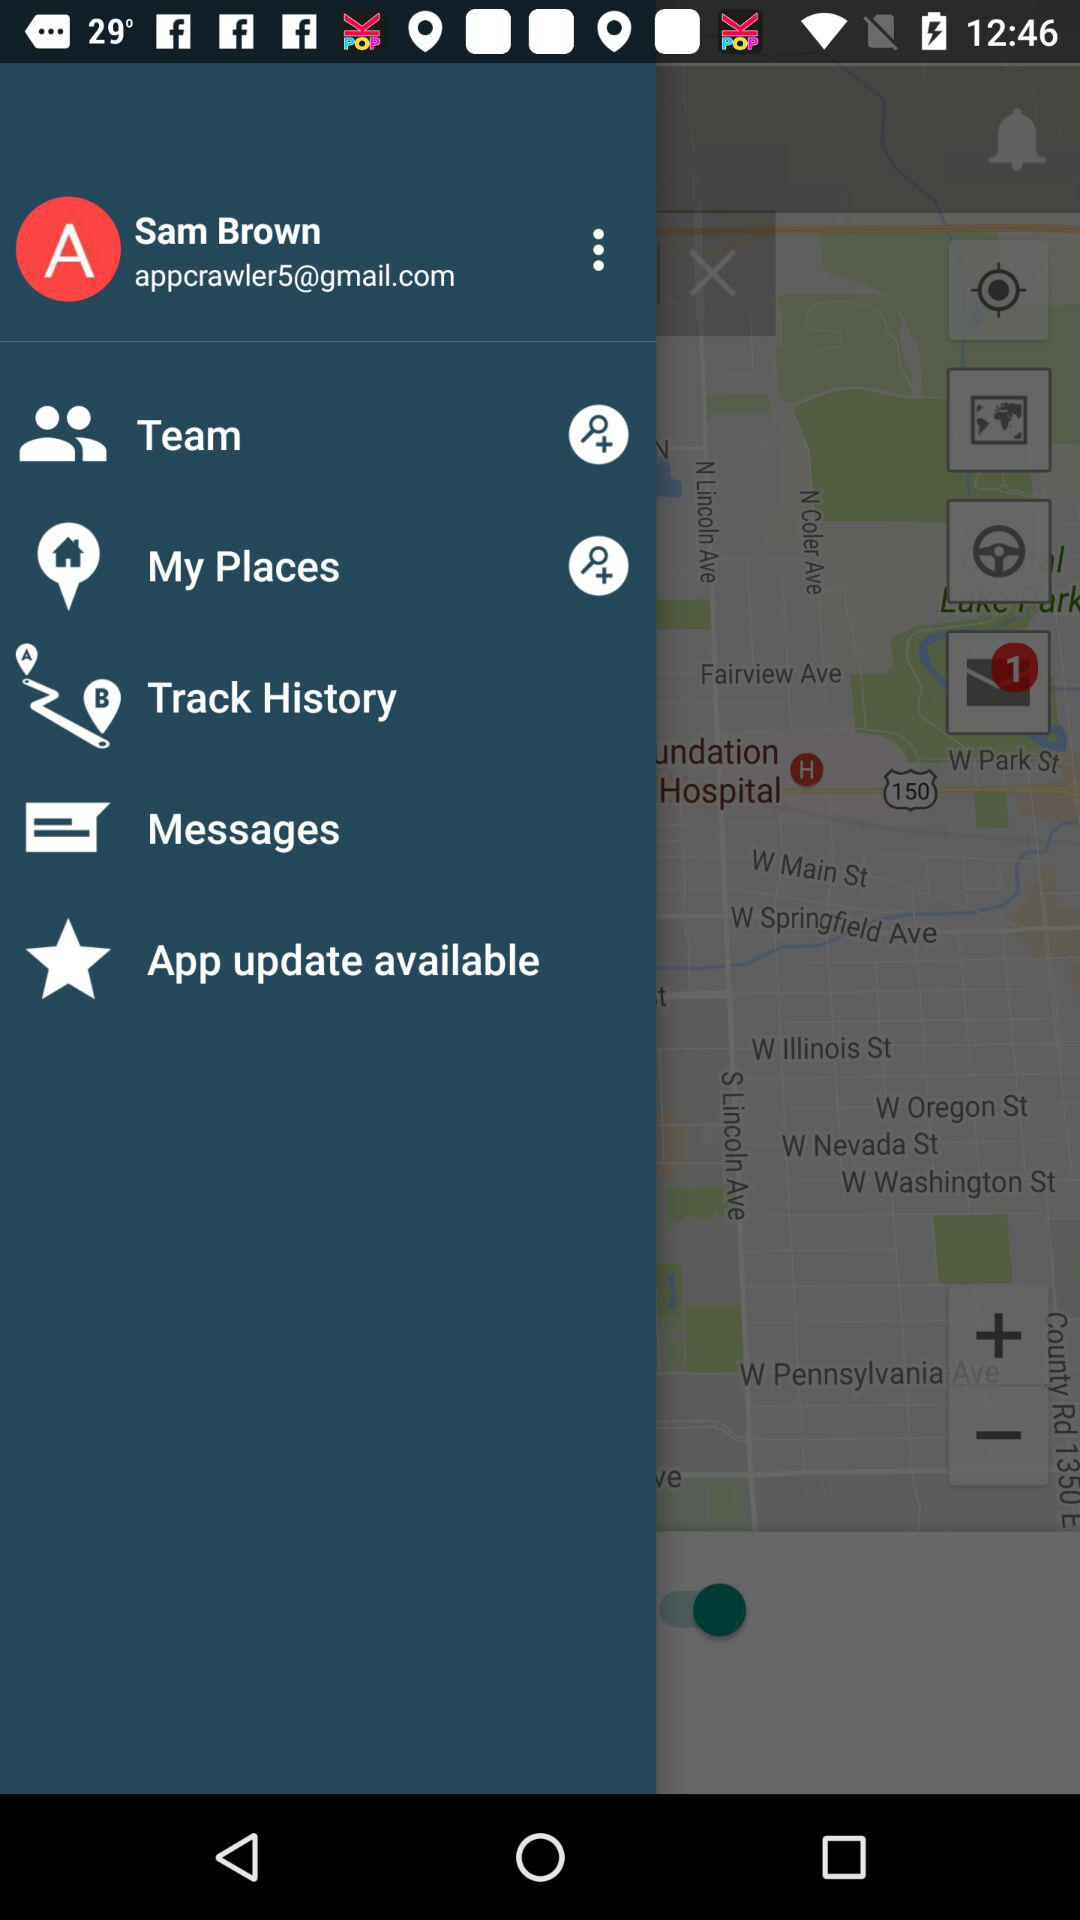What is the email address? The email address is "appcrawler5@gmail.com". 